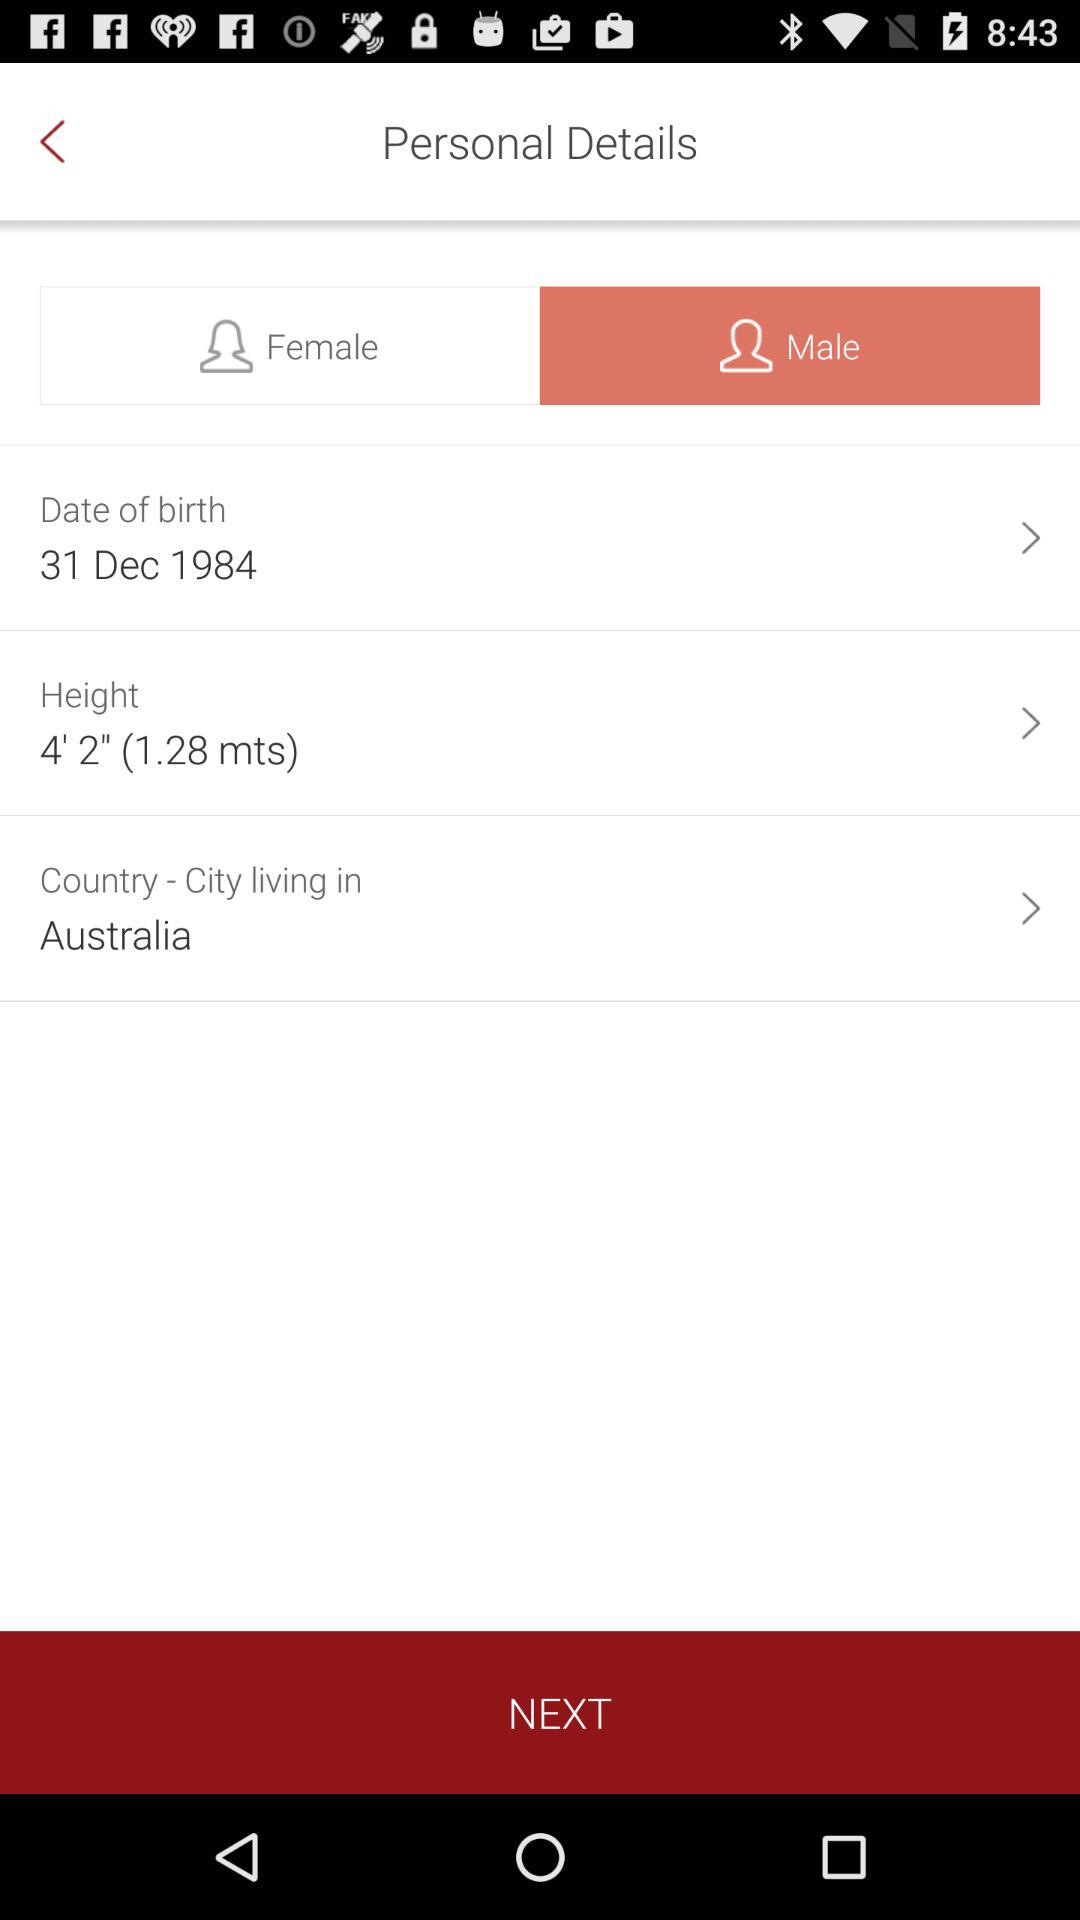What is the user's name?
When the provided information is insufficient, respond with <no answer>. <no answer> 